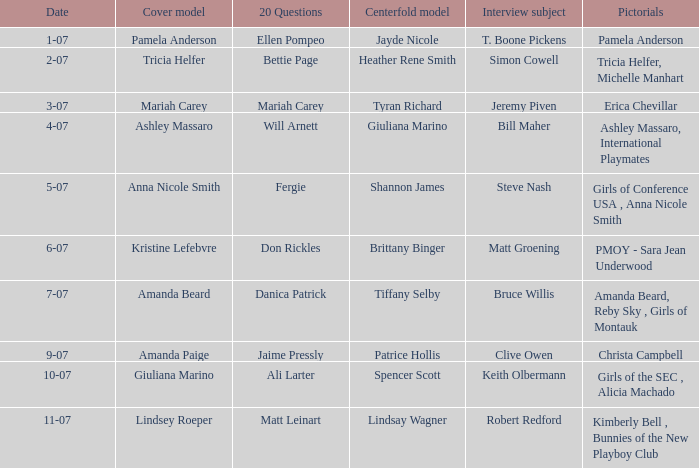Who was the cover model when the issue's pictorials was pmoy - sara jean underwood? Kristine Lefebvre. 